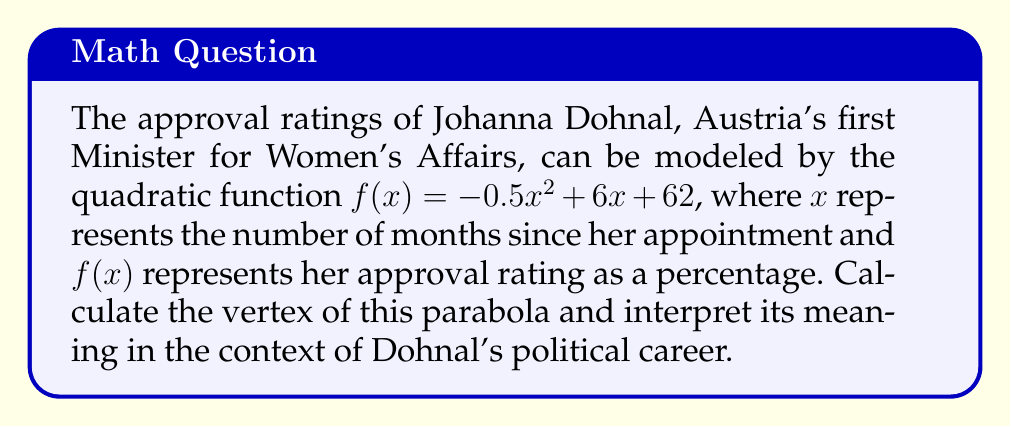What is the answer to this math problem? To find the vertex of a parabola given in the form $f(x) = ax^2 + bx + c$, we can use the formula:

$$x = -\frac{b}{2a}$$

Where $a$ and $b$ are the coefficients of $x^2$ and $x$ respectively.

For this parabola, we have:
$a = -0.5$
$b = 6$

Substituting these values into the formula:

$$x = -\frac{6}{2(-0.5)} = -\frac{6}{-1} = 6$$

To find the y-coordinate of the vertex, we substitute this x-value back into the original function:

$$\begin{align}
f(6) &= -0.5(6)^2 + 6(6) + 62 \\
&= -0.5(36) + 36 + 62 \\
&= -18 + 36 + 62 \\
&= 80
\end{align}$$

Therefore, the vertex of the parabola is (6, 80).

Interpreting this result:
The vertex represents the peak of Johanna Dohnal's approval ratings. Her approval reached its maximum of 80% after 6 months in office. After this point, her approval ratings began to decline.
Answer: The vertex of the parabola is (6, 80), meaning Johanna Dohnal's approval ratings peaked at 80% after 6 months in office. 